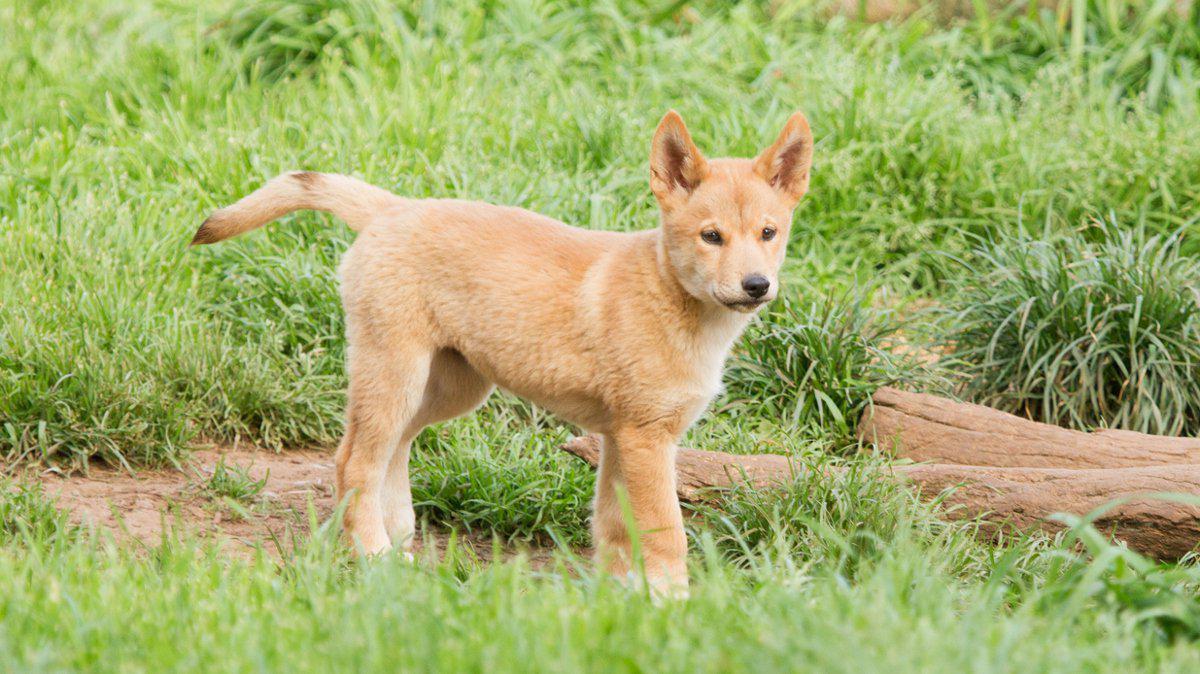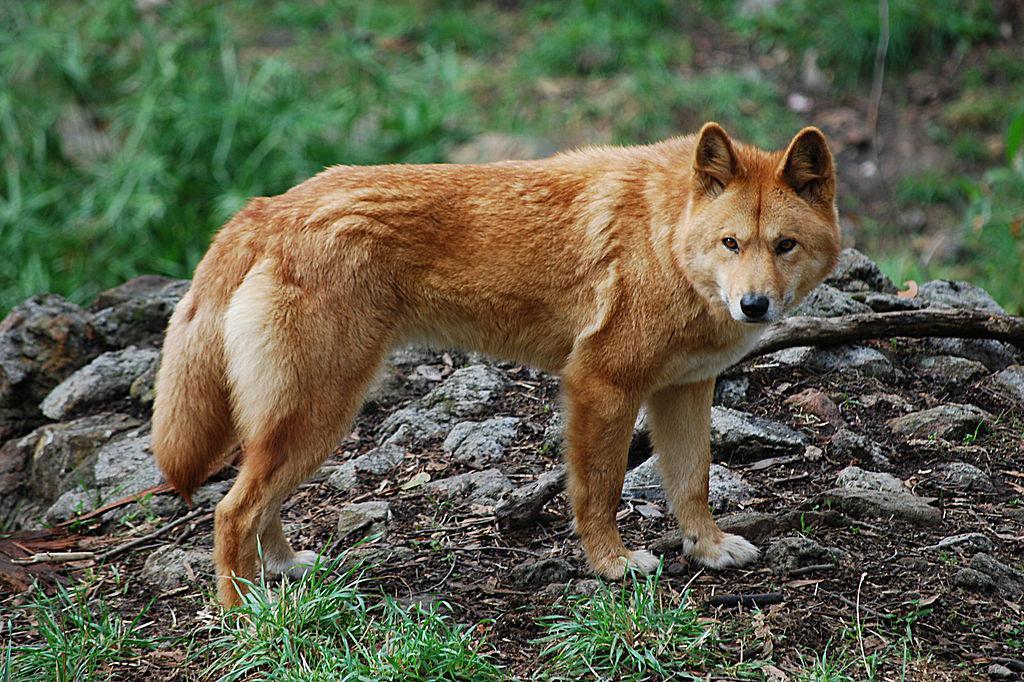The first image is the image on the left, the second image is the image on the right. Evaluate the accuracy of this statement regarding the images: "All dogs in the images are standing with all visible paws on the ground.". Is it true? Answer yes or no. Yes. 